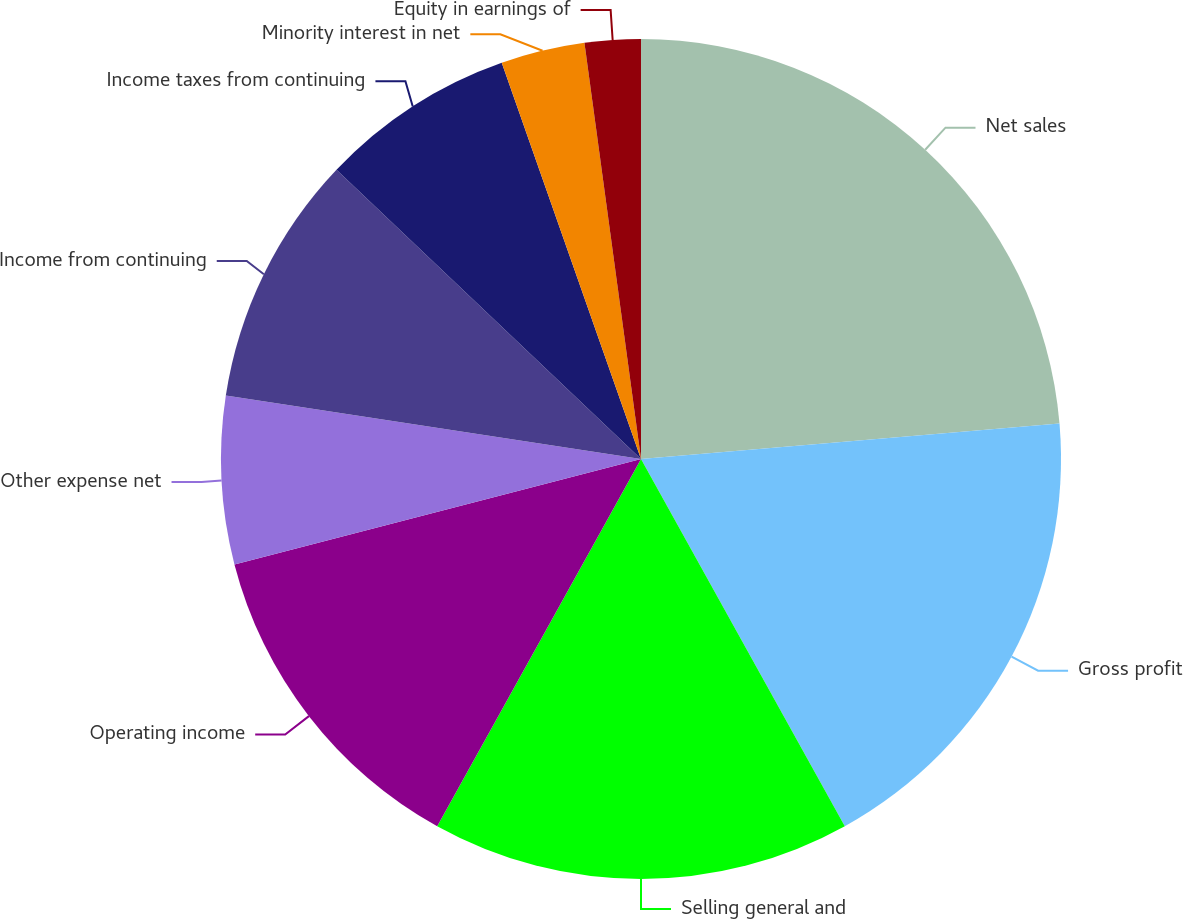Convert chart to OTSL. <chart><loc_0><loc_0><loc_500><loc_500><pie_chart><fcel>Net sales<fcel>Gross profit<fcel>Selling general and<fcel>Operating income<fcel>Other expense net<fcel>Income from continuing<fcel>Income taxes from continuing<fcel>Minority interest in net<fcel>Equity in earnings of<nl><fcel>23.66%<fcel>18.28%<fcel>16.13%<fcel>12.9%<fcel>6.45%<fcel>9.68%<fcel>7.53%<fcel>3.23%<fcel>2.15%<nl></chart> 